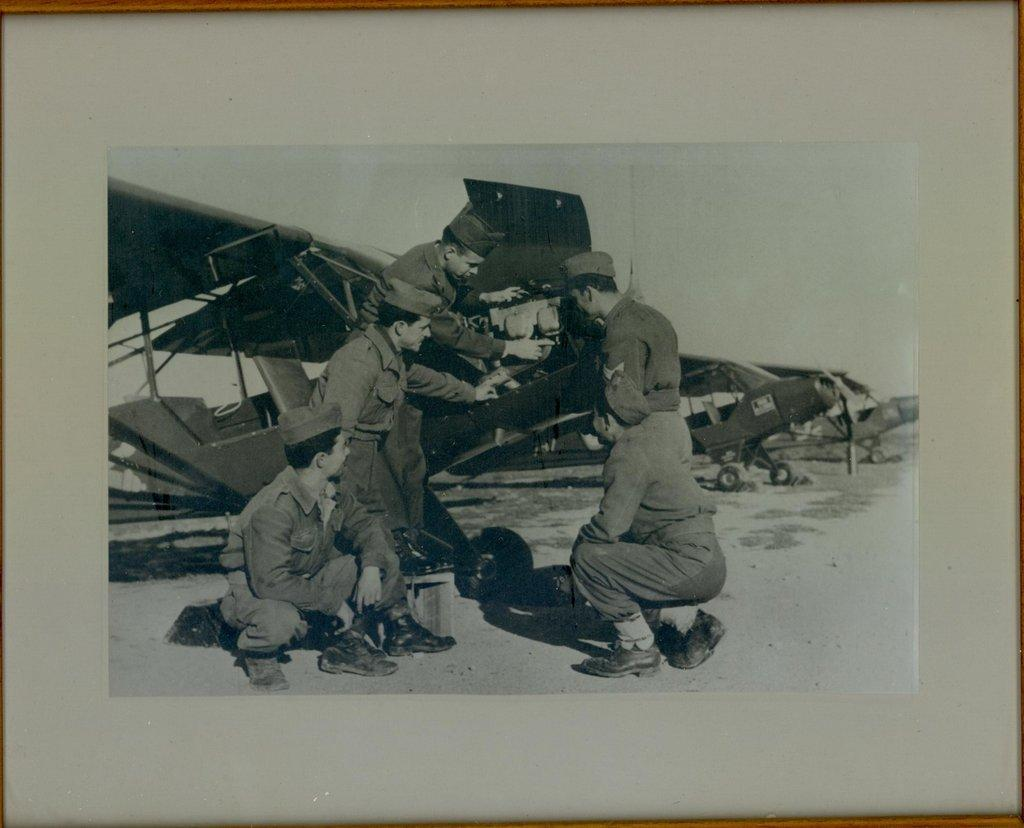What is the main object in the image? There is a photo frame in the image. What is depicted in the photo inside the frame? The photo contains people and airplanes. Are there any other objects visible in the photo? Yes, there are other objects present in the photo. Can you see any crumbs or cracks on the photo frame in the image? There is no mention of crumbs or cracks on the photo frame in the provided facts, so we cannot answer this question based on the information given. Are there any forks or cobwebs visible in the image? There is no mention of forks or cobwebs in the provided facts, so we cannot answer this question based on the information given. 